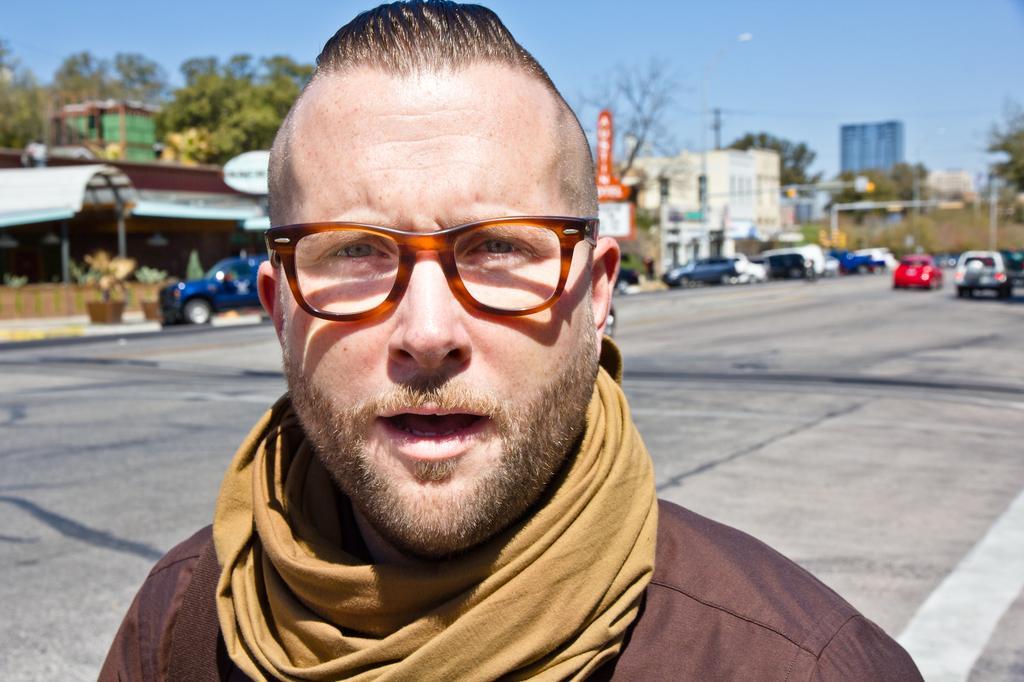How would you summarize this image in a sentence or two? In this image, we can see a person who is wearing some clothes and a scarf over his neck and the person is wearing spectacles and his mouth is open. At the back of the person there are some vehicles which are parked on the road and there are also some buildings. There are some buildings and we can even see sky, which is blue in color. 